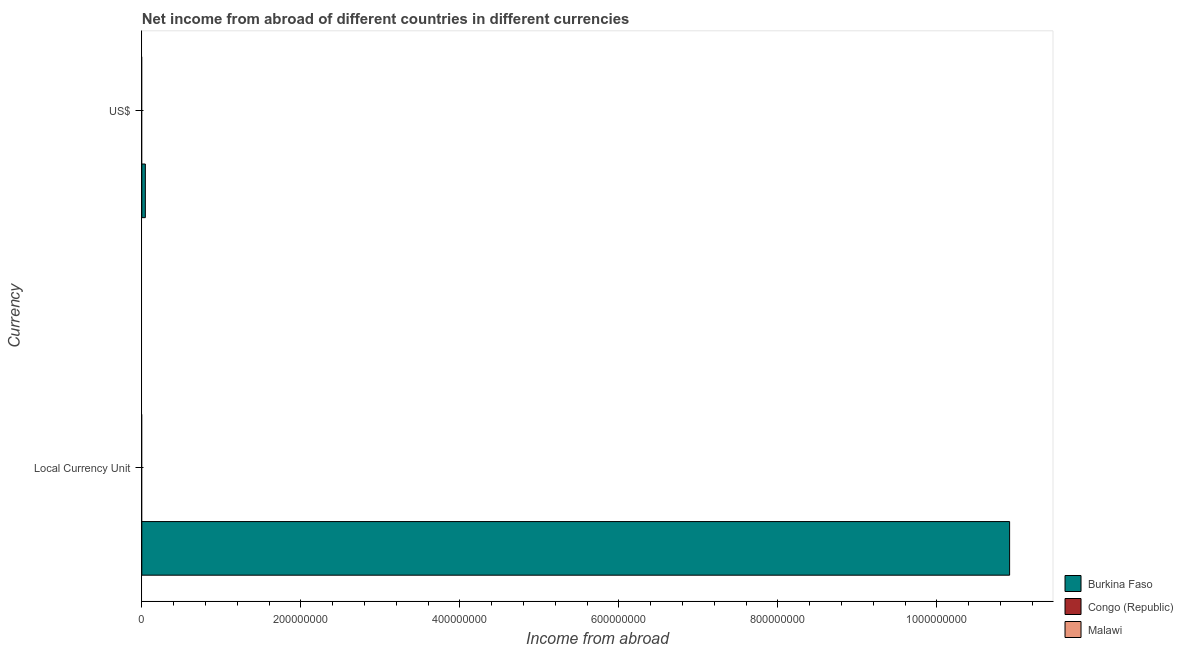How many different coloured bars are there?
Your answer should be very brief. 1. Are the number of bars per tick equal to the number of legend labels?
Provide a succinct answer. No. What is the label of the 1st group of bars from the top?
Give a very brief answer. US$. What is the income from abroad in us$ in Burkina Faso?
Your response must be concise. 4.45e+06. Across all countries, what is the maximum income from abroad in us$?
Your answer should be very brief. 4.45e+06. In which country was the income from abroad in us$ maximum?
Make the answer very short. Burkina Faso. What is the total income from abroad in us$ in the graph?
Offer a terse response. 4.45e+06. What is the difference between the income from abroad in constant 2005 us$ in Congo (Republic) and the income from abroad in us$ in Malawi?
Provide a short and direct response. 0. What is the average income from abroad in constant 2005 us$ per country?
Offer a very short reply. 3.64e+08. What is the difference between the income from abroad in constant 2005 us$ and income from abroad in us$ in Burkina Faso?
Your answer should be very brief. 1.09e+09. How many countries are there in the graph?
Give a very brief answer. 3. What is the difference between two consecutive major ticks on the X-axis?
Give a very brief answer. 2.00e+08. Are the values on the major ticks of X-axis written in scientific E-notation?
Your answer should be very brief. No. Does the graph contain any zero values?
Your response must be concise. Yes. Where does the legend appear in the graph?
Keep it short and to the point. Bottom right. How many legend labels are there?
Your answer should be compact. 3. How are the legend labels stacked?
Make the answer very short. Vertical. What is the title of the graph?
Provide a short and direct response. Net income from abroad of different countries in different currencies. Does "Chile" appear as one of the legend labels in the graph?
Give a very brief answer. No. What is the label or title of the X-axis?
Offer a very short reply. Income from abroad. What is the label or title of the Y-axis?
Your answer should be compact. Currency. What is the Income from abroad in Burkina Faso in Local Currency Unit?
Ensure brevity in your answer.  1.09e+09. What is the Income from abroad in Malawi in Local Currency Unit?
Provide a succinct answer. 0. What is the Income from abroad in Burkina Faso in US$?
Your answer should be compact. 4.45e+06. What is the Income from abroad of Malawi in US$?
Offer a terse response. 0. Across all Currency, what is the maximum Income from abroad of Burkina Faso?
Your answer should be very brief. 1.09e+09. Across all Currency, what is the minimum Income from abroad in Burkina Faso?
Give a very brief answer. 4.45e+06. What is the total Income from abroad in Burkina Faso in the graph?
Keep it short and to the point. 1.10e+09. What is the total Income from abroad of Malawi in the graph?
Ensure brevity in your answer.  0. What is the difference between the Income from abroad in Burkina Faso in Local Currency Unit and that in US$?
Offer a terse response. 1.09e+09. What is the average Income from abroad in Burkina Faso per Currency?
Ensure brevity in your answer.  5.48e+08. What is the average Income from abroad in Malawi per Currency?
Give a very brief answer. 0. What is the ratio of the Income from abroad in Burkina Faso in Local Currency Unit to that in US$?
Your answer should be very brief. 245.2. What is the difference between the highest and the second highest Income from abroad in Burkina Faso?
Provide a succinct answer. 1.09e+09. What is the difference between the highest and the lowest Income from abroad in Burkina Faso?
Offer a very short reply. 1.09e+09. 